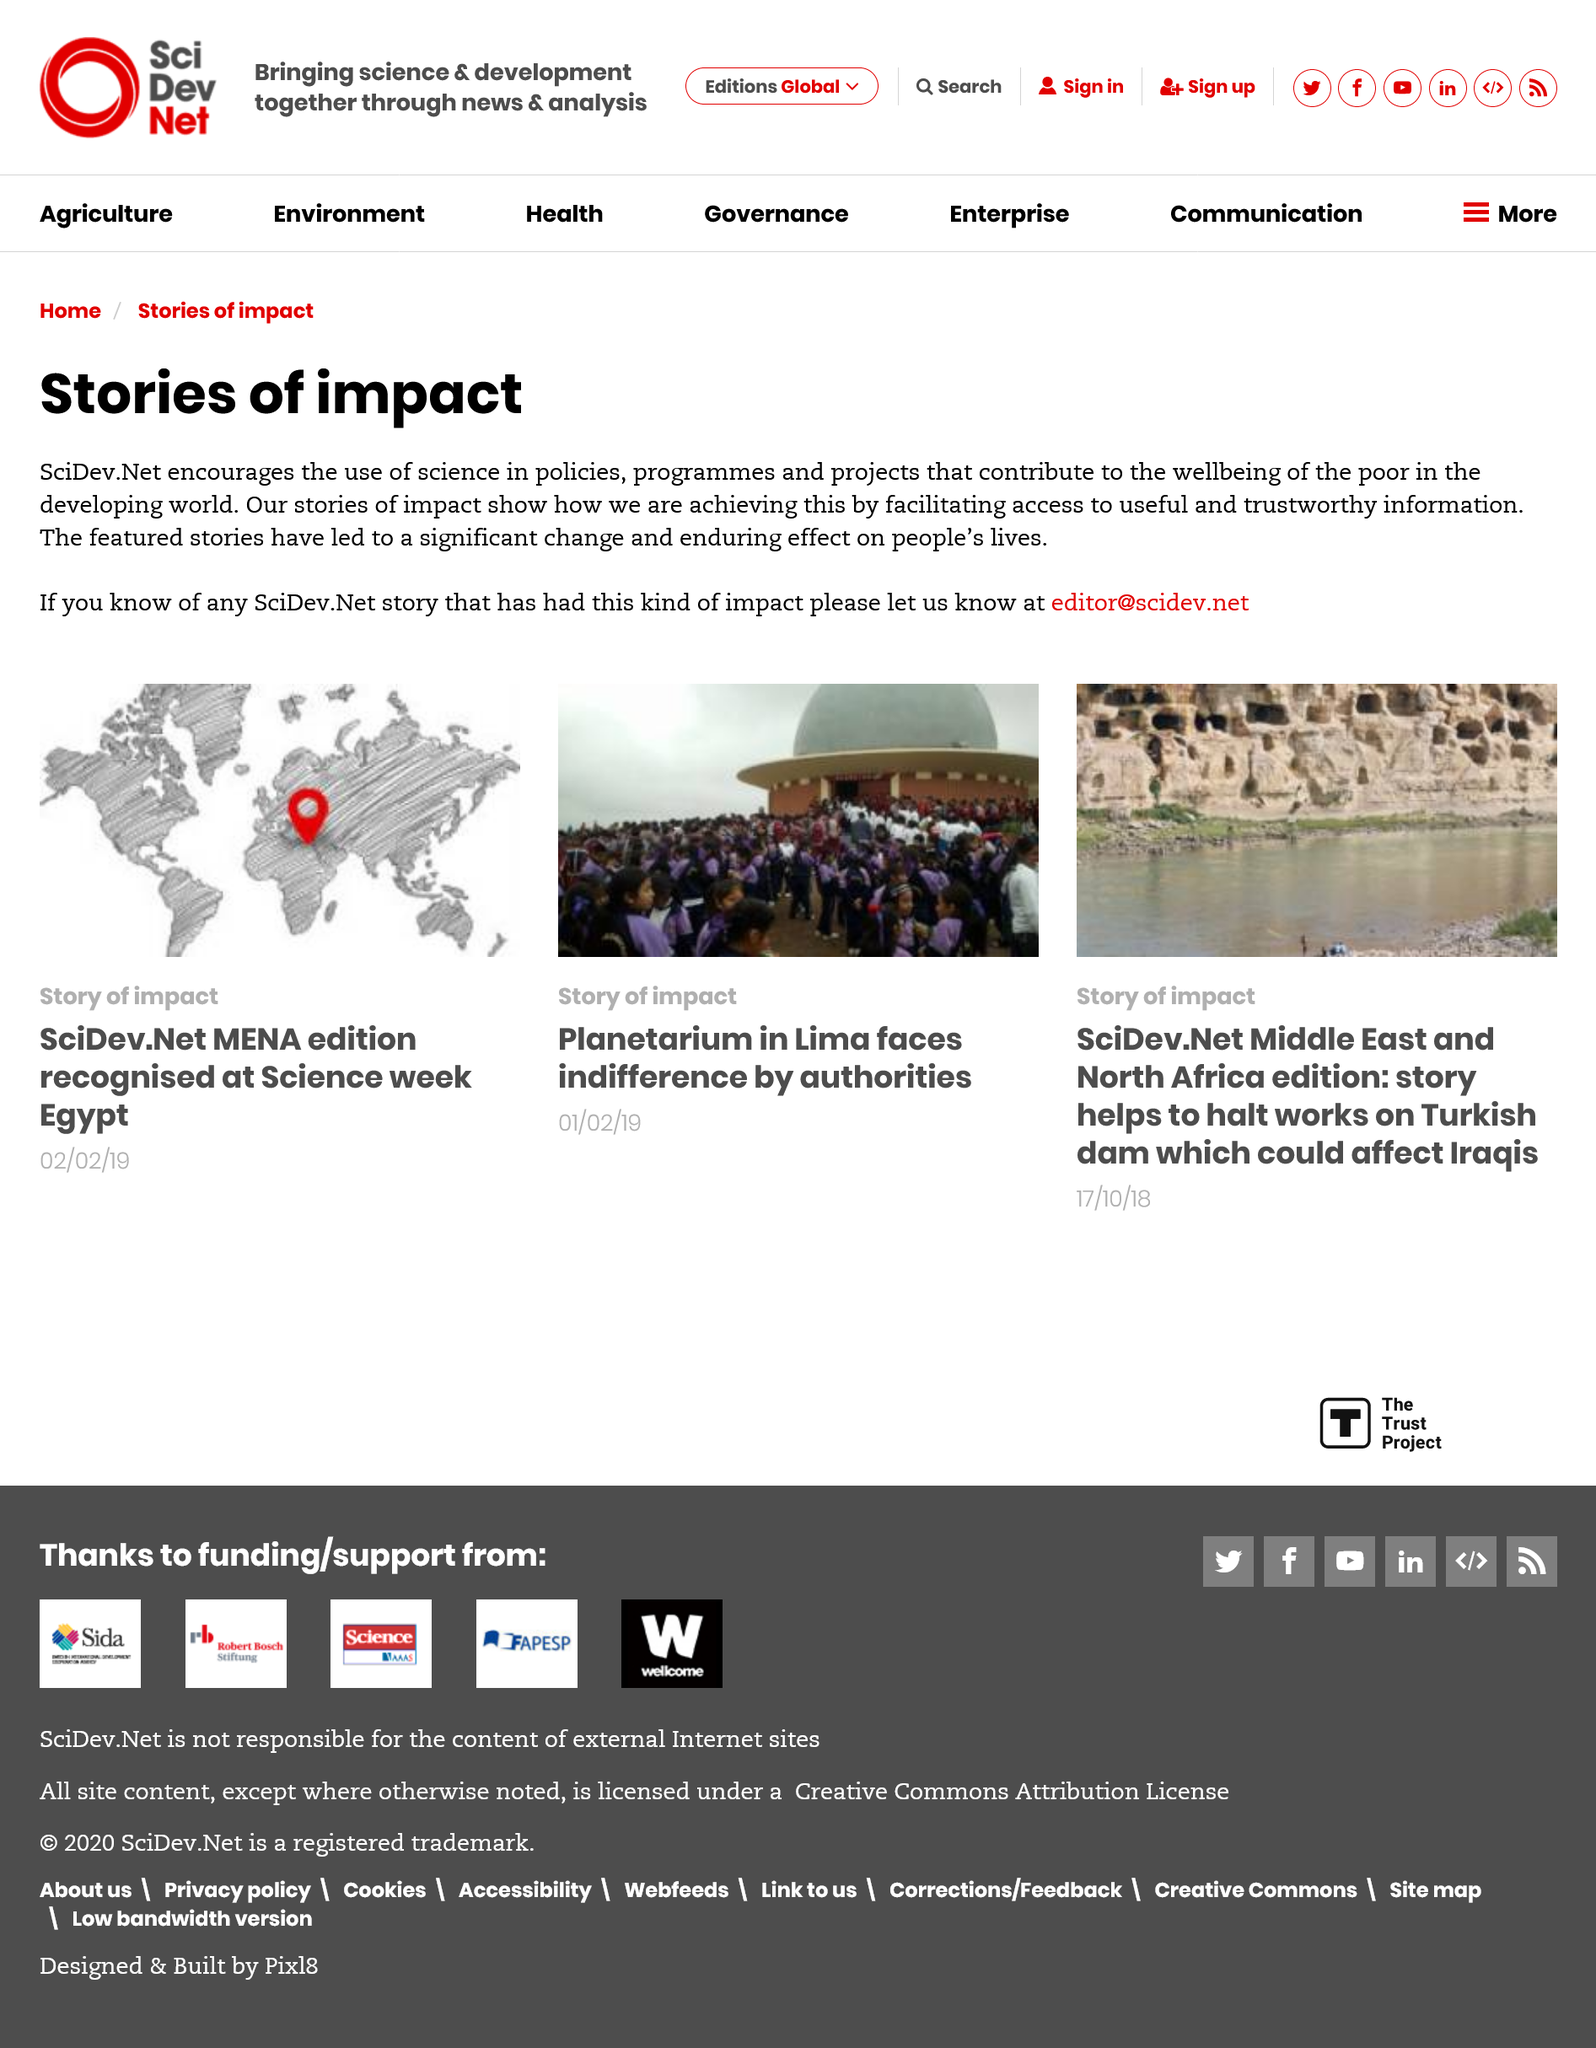Highlight a few significant elements in this photo. It is possible to make submissions to the website. There are three additional articles on the page. The arrow points to Egypt, as declared. 